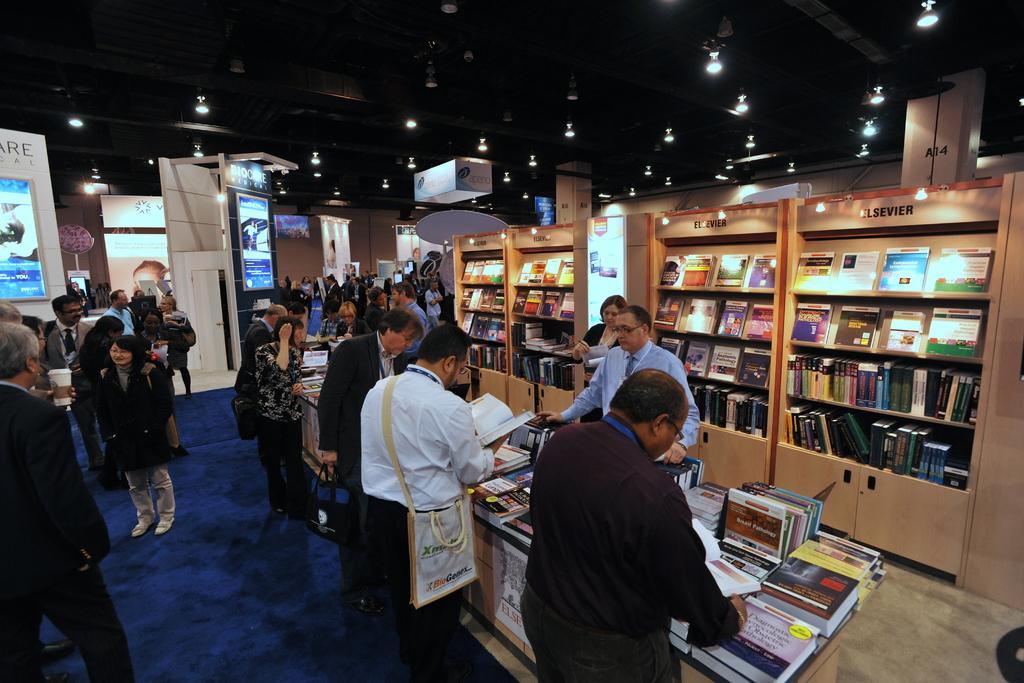Can you describe this image briefly? Here in this picture we can see number of people standing on the floor over there and we can see racks present, which are full of books over there and we can also see a table, on which we can see number of books present and we can see banners present here and there and we can see the roof fully covered with lights over there. 